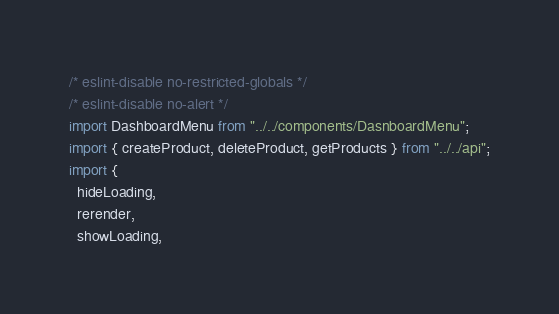<code> <loc_0><loc_0><loc_500><loc_500><_JavaScript_>/* eslint-disable no-restricted-globals */
/* eslint-disable no-alert */
import DashboardMenu from "../../components/DasnboardMenu";
import { createProduct, deleteProduct, getProducts } from "../../api";
import {
  hideLoading,
  rerender,
  showLoading,</code> 